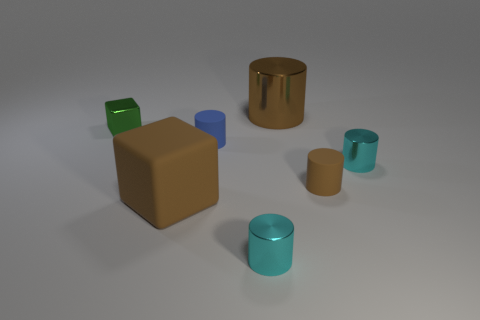There is a shiny cylinder that is behind the blue cylinder; does it have the same size as the green metallic cube?
Provide a succinct answer. No. The object that is both on the left side of the tiny blue thing and behind the brown cube has what shape?
Provide a succinct answer. Cube. Does the large matte block have the same color as the rubber object behind the tiny brown thing?
Provide a succinct answer. No. There is a small metal object behind the small cyan thing behind the tiny cyan metal cylinder that is to the left of the tiny brown cylinder; what color is it?
Offer a terse response. Green. What is the color of the big object that is the same shape as the small green shiny thing?
Give a very brief answer. Brown. Are there an equal number of brown matte cylinders in front of the tiny brown cylinder and small blue cylinders?
Your answer should be compact. No. How many balls are either brown shiny things or tiny objects?
Provide a short and direct response. 0. There is a big thing that is the same material as the tiny block; what color is it?
Your answer should be compact. Brown. Does the tiny block have the same material as the brown cylinder that is in front of the tiny blue rubber cylinder?
Your answer should be compact. No. How many things are either brown cylinders or matte objects?
Your response must be concise. 4. 